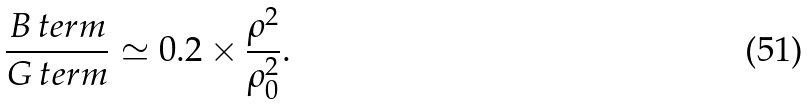<formula> <loc_0><loc_0><loc_500><loc_500>\frac { B \, t e r m } { G \, t e r m } \simeq 0 . 2 \times \frac { \rho ^ { 2 } } { \rho _ { 0 } ^ { 2 } } .</formula> 